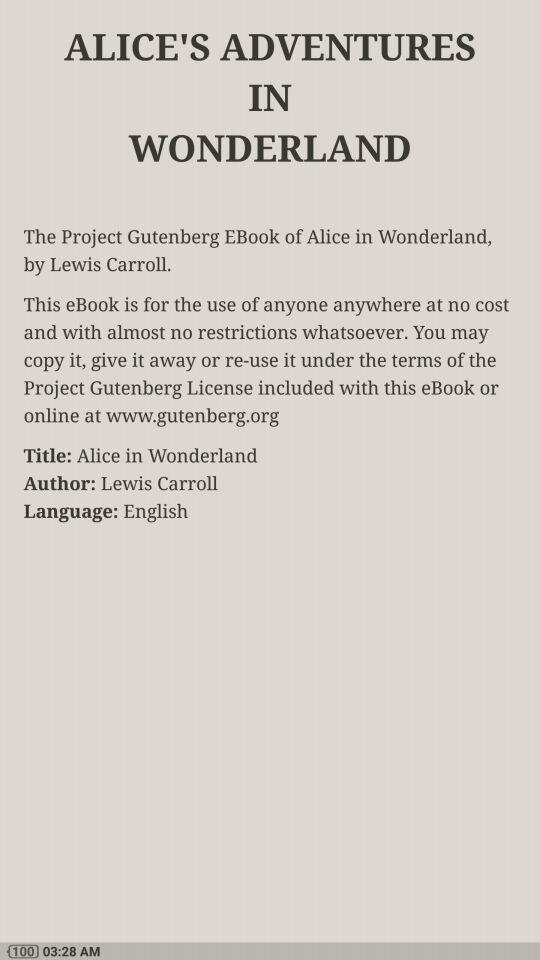What is the shown time? The shown time is 3:28 a.m. 